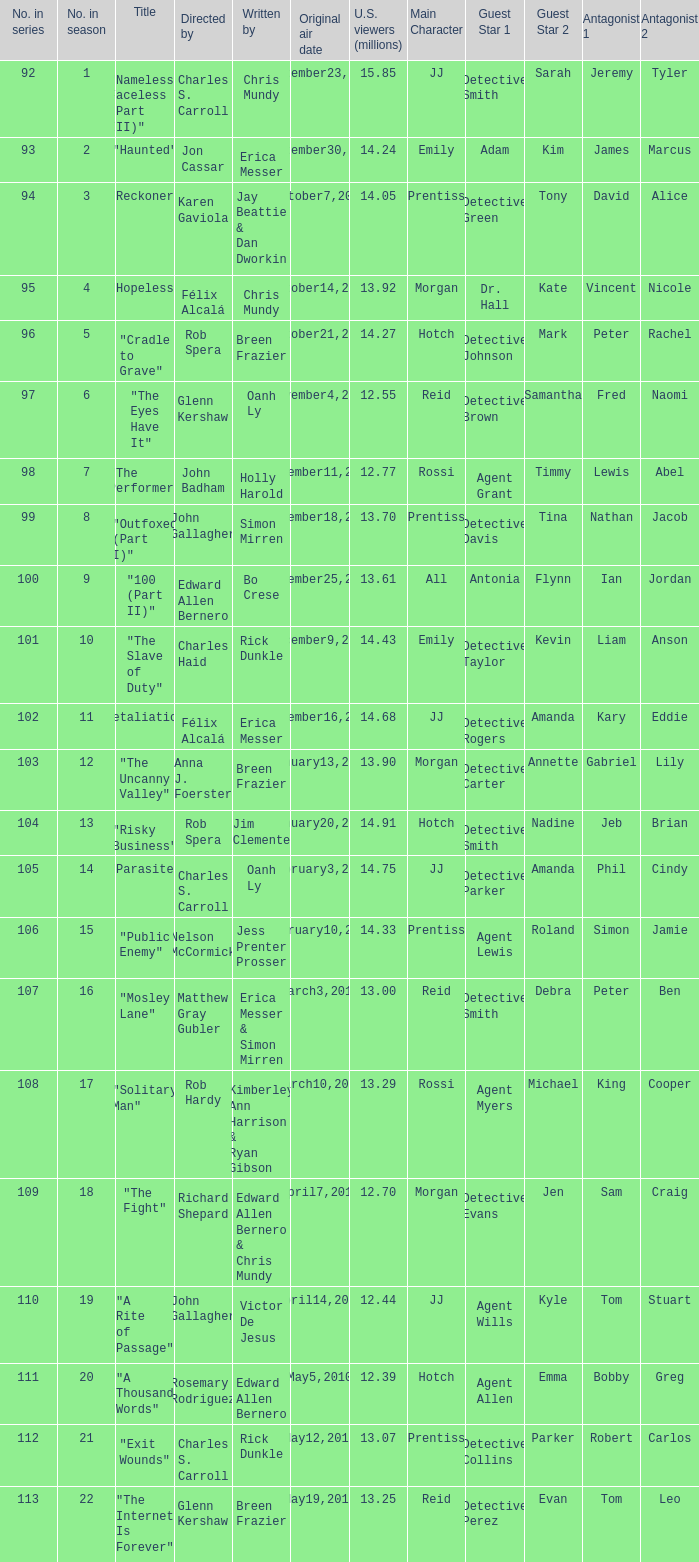What season was the episode "haunted" in? 2.0. 